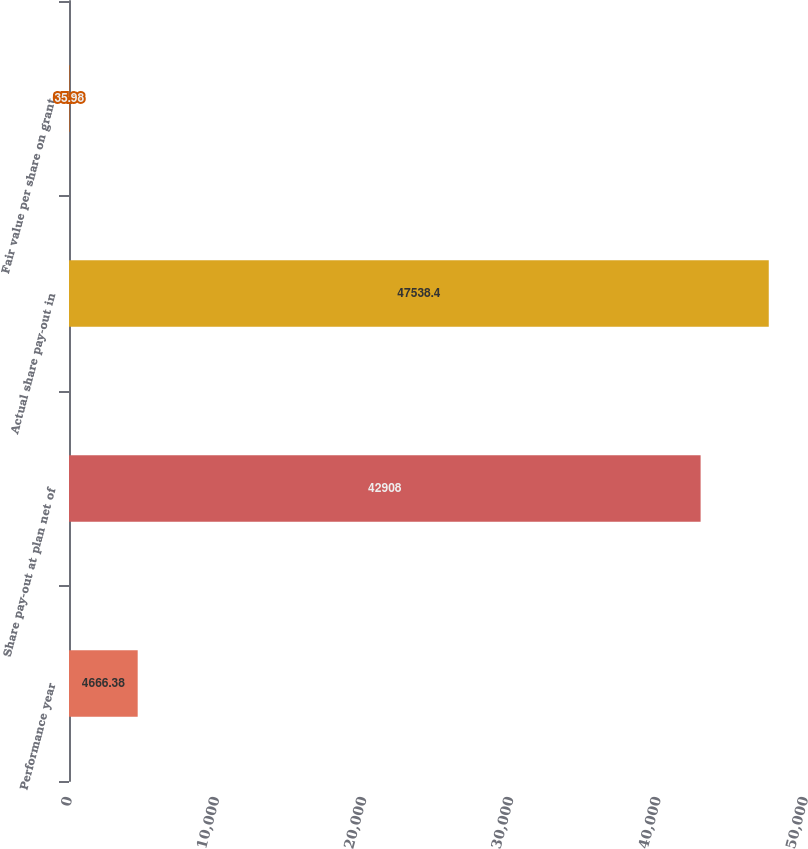<chart> <loc_0><loc_0><loc_500><loc_500><bar_chart><fcel>Performance year<fcel>Share pay-out at plan net of<fcel>Actual share pay-out in<fcel>Fair value per share on grant<nl><fcel>4666.38<fcel>42908<fcel>47538.4<fcel>35.98<nl></chart> 